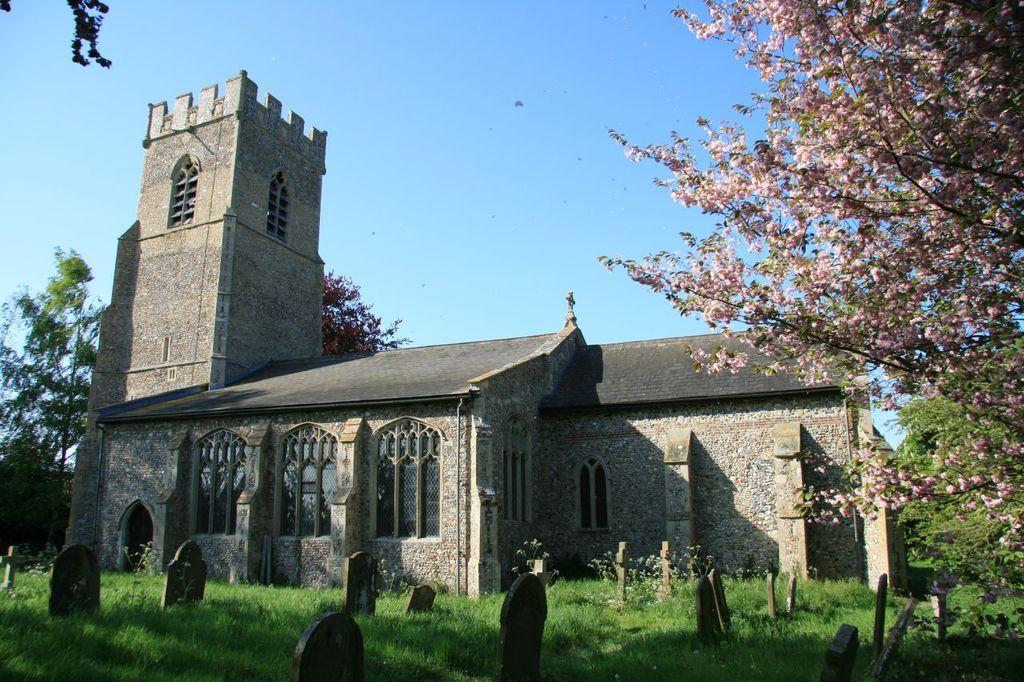In one or two sentences, can you explain what this image depicts? At the center of the image there is a building, in front of the building there is a graveyard. On the left and right side of the image there are trees and flowers. In the background there is the sky. 